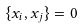<formula> <loc_0><loc_0><loc_500><loc_500>\{ x _ { i } , x _ { j } \} = 0</formula> 